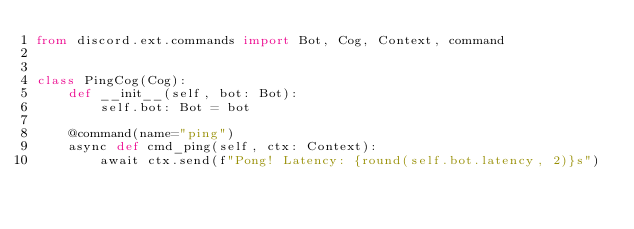Convert code to text. <code><loc_0><loc_0><loc_500><loc_500><_Python_>from discord.ext.commands import Bot, Cog, Context, command


class PingCog(Cog):
    def __init__(self, bot: Bot):
        self.bot: Bot = bot

    @command(name="ping")
    async def cmd_ping(self, ctx: Context):
        await ctx.send(f"Pong! Latency: {round(self.bot.latency, 2)}s")
</code> 